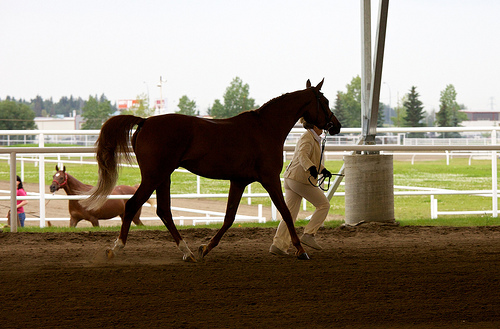<image>
Is the horse on the ground? Yes. Looking at the image, I can see the horse is positioned on top of the ground, with the ground providing support. 